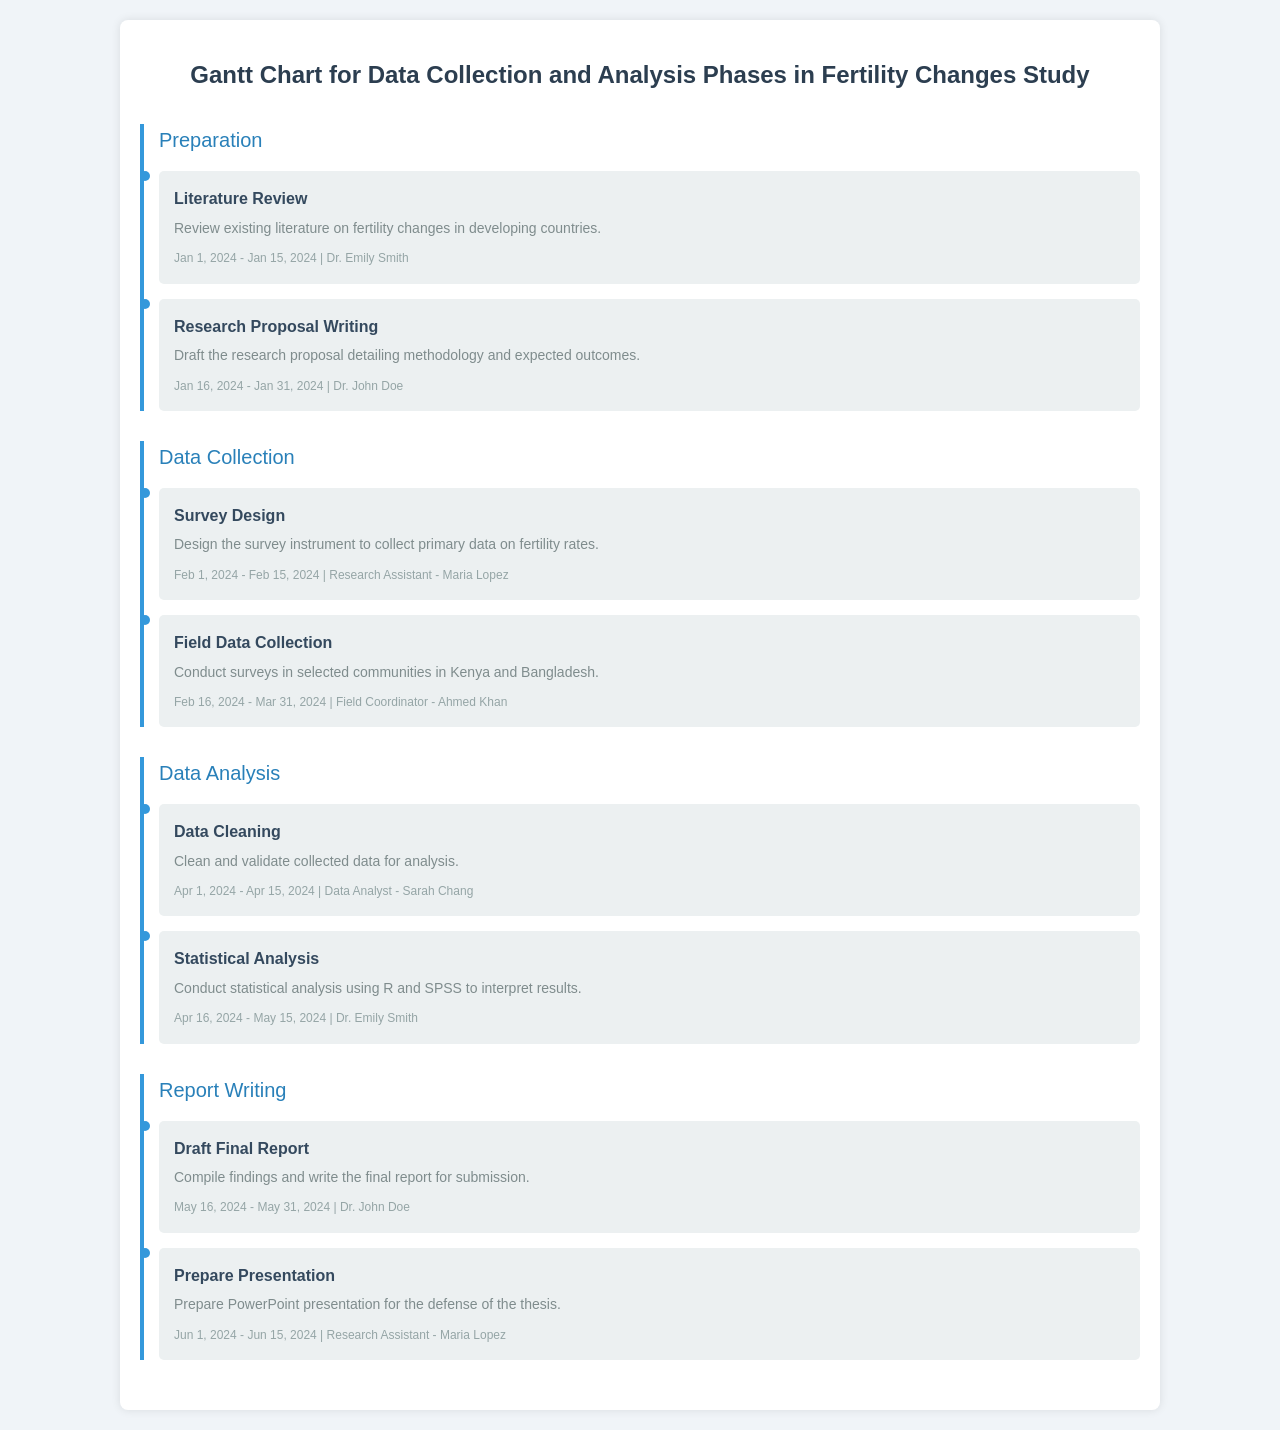What is the title of the study? The title of the study is the heading of the document, reflecting its main focus.
Answer: Gantt Chart for Data Collection and Analysis Phases in Fertility Changes Study Who is responsible for the literature review? The responsible person is listed for the task of literature review in the preparation phase.
Answer: Dr. Emily Smith What are the dates for field data collection? The field data collection period is specified within the task details.
Answer: February 16, 2024 - March 31, 2024 What task follows survey design? This refers to the task that is next in order under the same phase.
Answer: Field Data Collection When does statistical analysis begin? The start date for statistical analysis is detailed under the data analysis phase.
Answer: April 16, 2024 How many weeks are allocated for data cleaning? The duration of the data cleaning task is derived from its start and end dates.
Answer: Two weeks Who is tasked with preparing the presentation? This refers to the individual identified for the specific task of preparing the presentation.
Answer: Research Assistant - Maria Lopez Which phase includes drafting the final report? The phase where this task is located is indicated in the document.
Answer: Report Writing What is the color code used for tasks in the document? The color code for tasks is mentioned in the task design description.
Answer: Light gray (ecf0f1) 